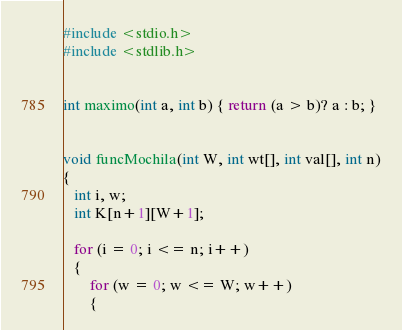<code> <loc_0><loc_0><loc_500><loc_500><_C_>#include <stdio.h>
#include <stdlib.h>
 

int maximo(int a, int b) { return (a > b)? a : b; }
 

void funcMochila(int W, int wt[], int val[], int n)
{
   int i, w;
   int K[n+1][W+1];

   for (i = 0; i <= n; i++)
   {
       for (w = 0; w <= W; w++)
       {</code> 